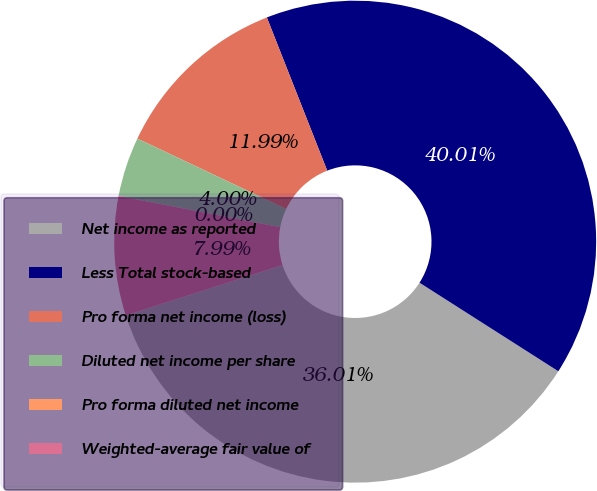<chart> <loc_0><loc_0><loc_500><loc_500><pie_chart><fcel>Net income as reported<fcel>Less Total stock-based<fcel>Pro forma net income (loss)<fcel>Diluted net income per share<fcel>Pro forma diluted net income<fcel>Weighted-average fair value of<nl><fcel>36.01%<fcel>40.01%<fcel>11.99%<fcel>4.0%<fcel>0.0%<fcel>7.99%<nl></chart> 